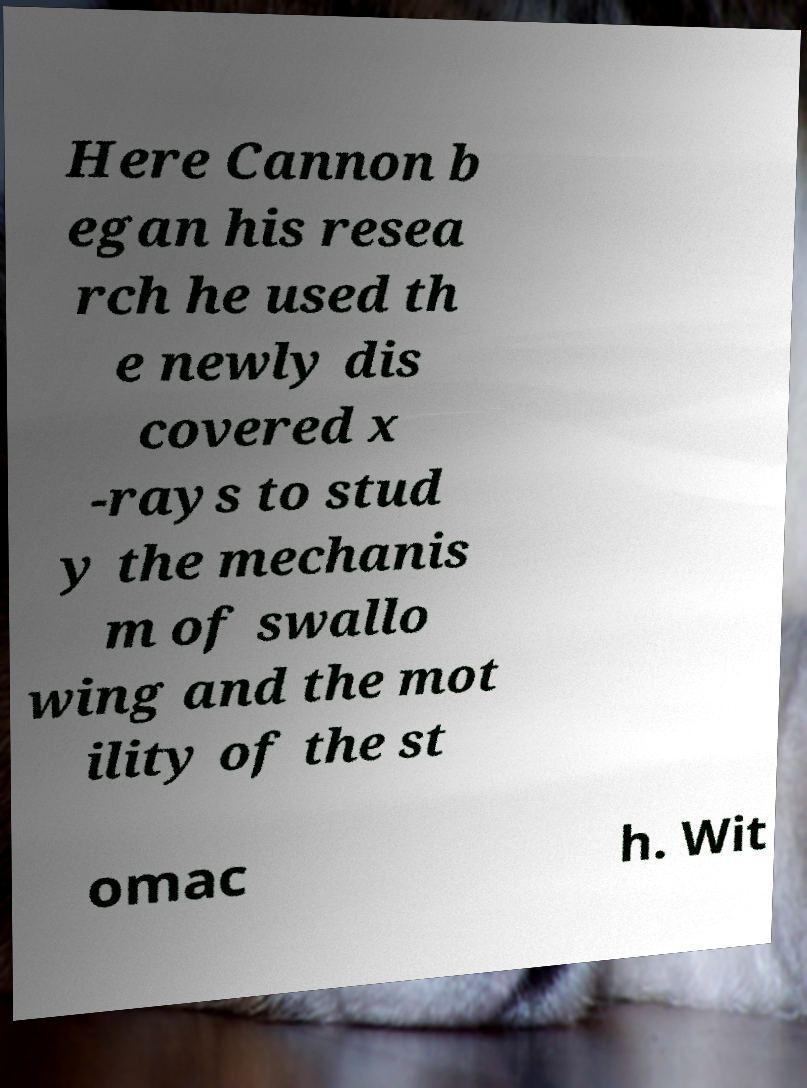Please read and relay the text visible in this image. What does it say? Here Cannon b egan his resea rch he used th e newly dis covered x -rays to stud y the mechanis m of swallo wing and the mot ility of the st omac h. Wit 